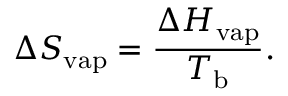<formula> <loc_0><loc_0><loc_500><loc_500>\Delta S _ { v a p } = { \frac { \Delta H _ { v a p } } { T _ { b } } } .</formula> 